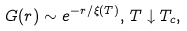<formula> <loc_0><loc_0><loc_500><loc_500>G ( r ) \sim e ^ { - r / \xi ( T ) } , \, T \downarrow T _ { c } ,</formula> 